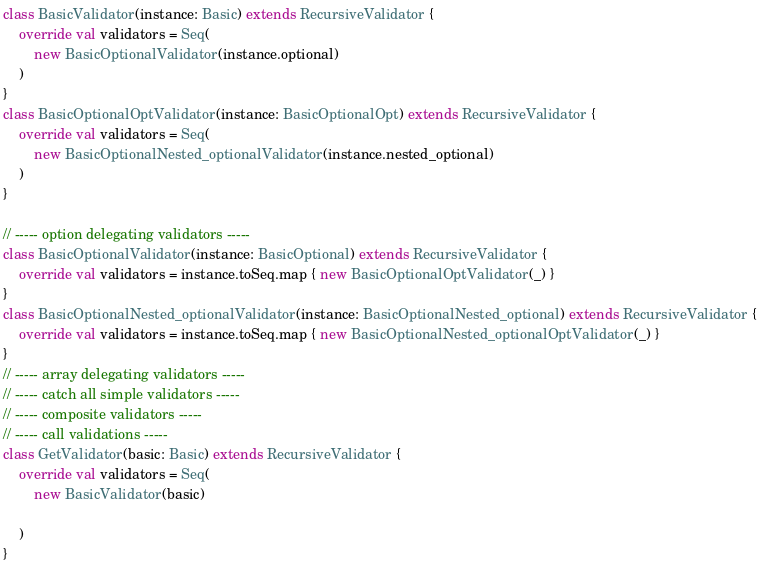Convert code to text. <code><loc_0><loc_0><loc_500><loc_500><_Scala_>class BasicValidator(instance: Basic) extends RecursiveValidator {
    override val validators = Seq(
        new BasicOptionalValidator(instance.optional)
    )
}
class BasicOptionalOptValidator(instance: BasicOptionalOpt) extends RecursiveValidator {
    override val validators = Seq(
        new BasicOptionalNested_optionalValidator(instance.nested_optional)
    )
}

// ----- option delegating validators -----
class BasicOptionalValidator(instance: BasicOptional) extends RecursiveValidator {
    override val validators = instance.toSeq.map { new BasicOptionalOptValidator(_) }
}
class BasicOptionalNested_optionalValidator(instance: BasicOptionalNested_optional) extends RecursiveValidator {
    override val validators = instance.toSeq.map { new BasicOptionalNested_optionalOptValidator(_) }
}
// ----- array delegating validators -----
// ----- catch all simple validators -----
// ----- composite validators -----
// ----- call validations -----
class GetValidator(basic: Basic) extends RecursiveValidator {
    override val validators = Seq(
        new BasicValidator(basic)
    
    )
}
</code> 